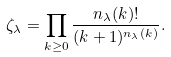Convert formula to latex. <formula><loc_0><loc_0><loc_500><loc_500>\zeta _ { \lambda } & = \prod _ { k \geq 0 } \frac { n _ { \lambda } ( k ) ! } { ( k + 1 ) ^ { n _ { \lambda } ( k ) } } .</formula> 